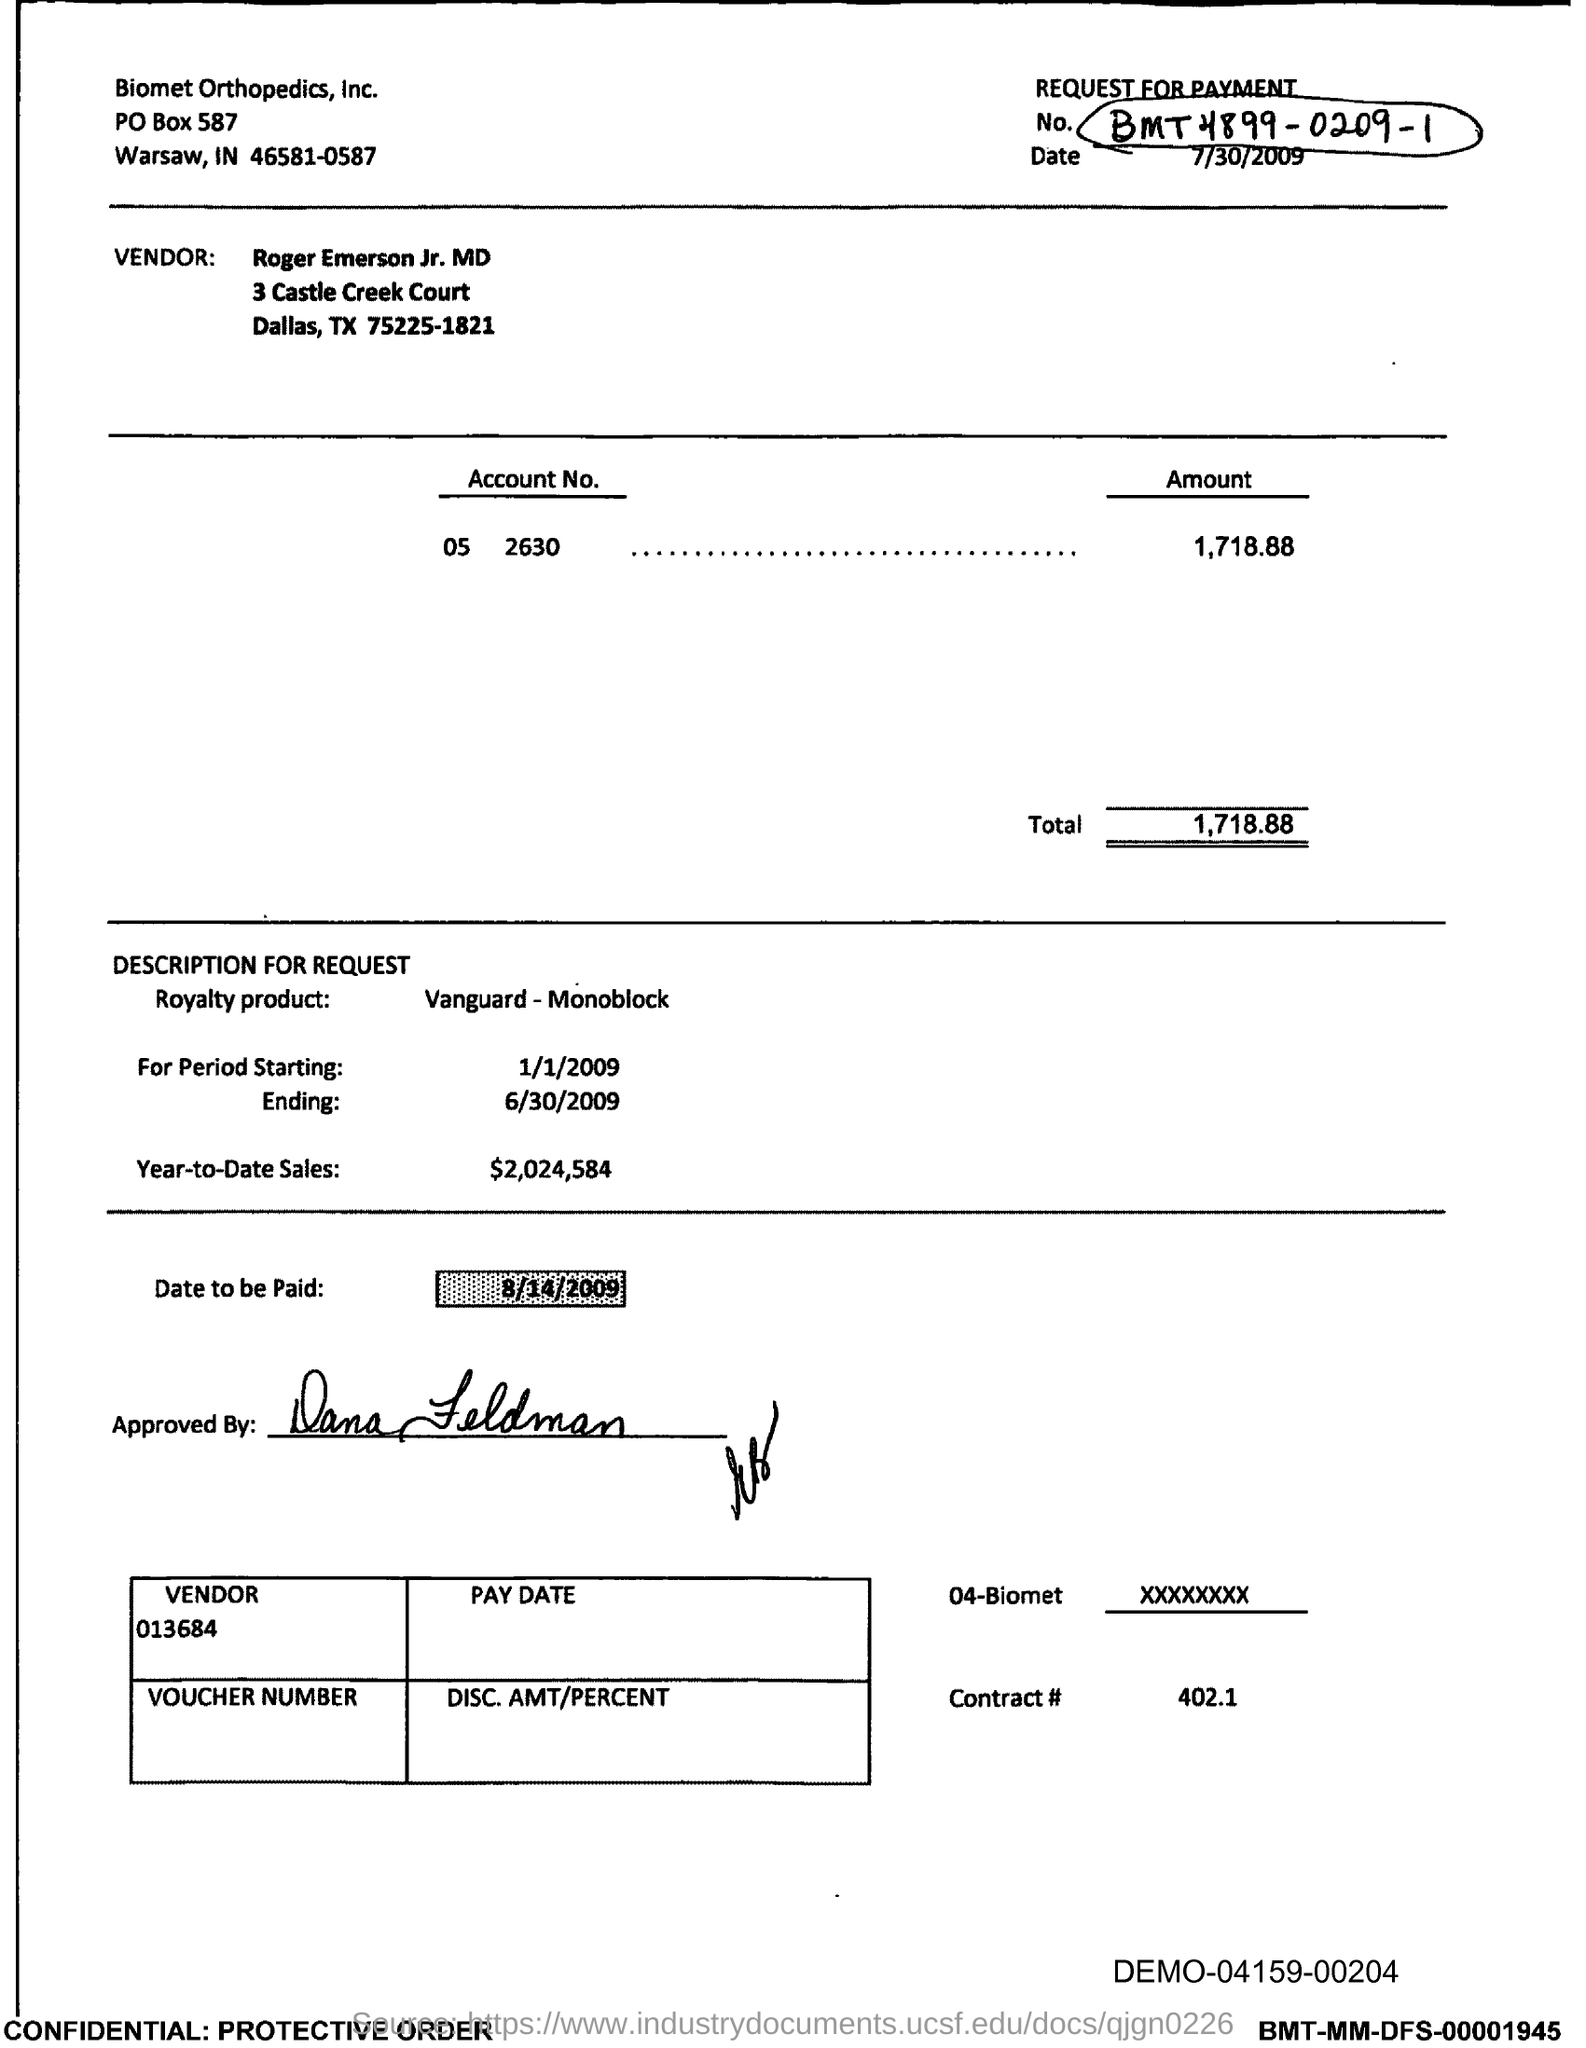What is the Total?
Your answer should be very brief. 1,718.88. What is the Year-to-Date-Sales?
Your answer should be very brief. $2,024,584. 